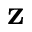<formula> <loc_0><loc_0><loc_500><loc_500>z</formula> 